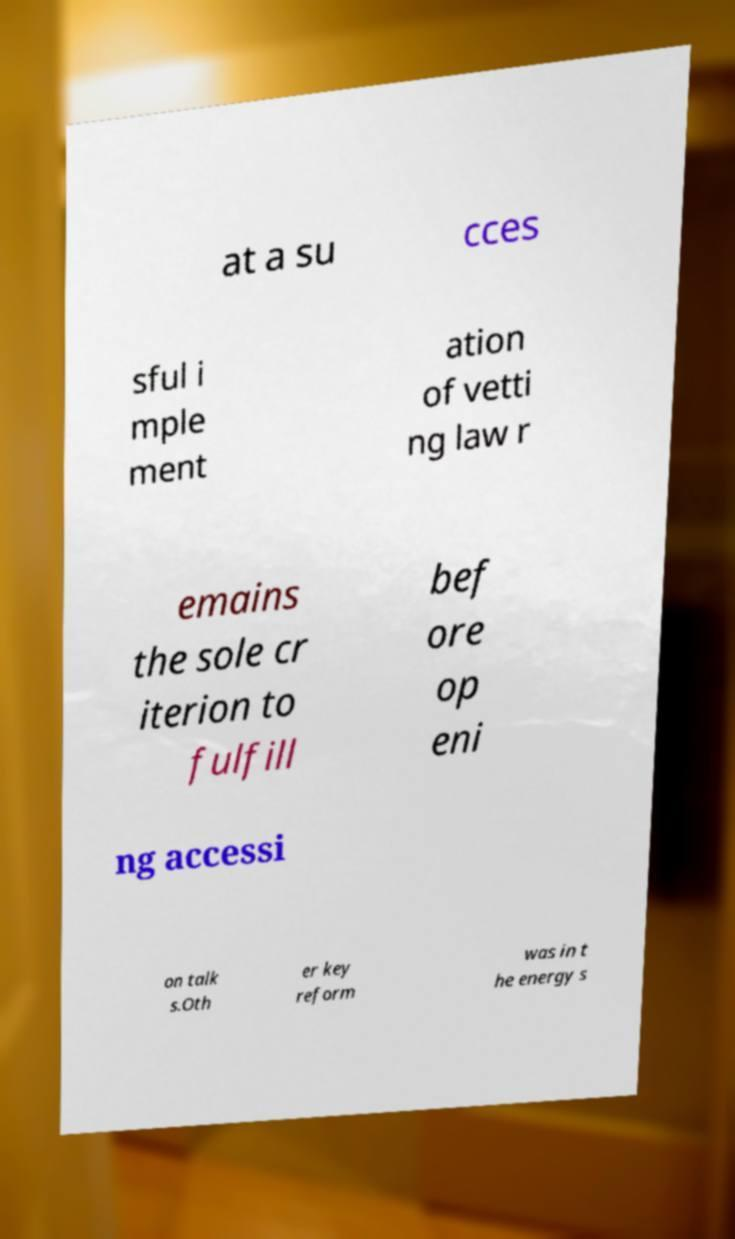For documentation purposes, I need the text within this image transcribed. Could you provide that? at a su cces sful i mple ment ation of vetti ng law r emains the sole cr iterion to fulfill bef ore op eni ng accessi on talk s.Oth er key reform was in t he energy s 